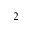Convert formula to latex. <formula><loc_0><loc_0><loc_500><loc_500>^ { 2 }</formula> 